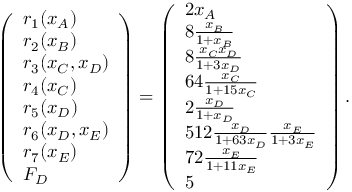Convert formula to latex. <formula><loc_0><loc_0><loc_500><loc_500>\left ( \begin{array} { l } { r _ { 1 } ( x _ { A } ) } \\ { r _ { 2 } ( x _ { B } ) } \\ { r _ { 3 } ( x _ { C } , x _ { D } ) } \\ { r _ { 4 } ( x _ { C } ) } \\ { r _ { 5 } ( x _ { D } ) } \\ { r _ { 6 } ( x _ { D } , x _ { E } ) } \\ { r _ { 7 } ( x _ { E } ) } \\ { F _ { D } } \end{array} \right ) = \left ( \begin{array} { l } { 2 x _ { A } } \\ { 8 \frac { x _ { B } } { 1 + x _ { B } } } \\ { 8 \frac { x _ { C } x _ { D } } { 1 + 3 x _ { D } } } \\ { 6 4 \frac { x _ { C } } { 1 + 1 5 x _ { C } } } \\ { 2 \frac { x _ { D } } { 1 + x _ { D } } } \\ { 5 1 2 \frac { x _ { D } } { 1 + 6 3 x _ { D } } \frac { x _ { E } } { 1 + 3 x _ { E } } } \\ { 7 2 \frac { x _ { E } } { 1 + 1 1 x _ { E } } } \\ { 5 } \end{array} \right ) .</formula> 